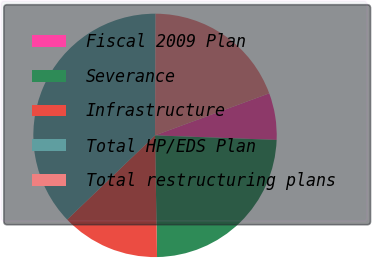Convert chart to OTSL. <chart><loc_0><loc_0><loc_500><loc_500><pie_chart><fcel>Fiscal 2009 Plan<fcel>Severance<fcel>Infrastructure<fcel>Total HP/EDS Plan<fcel>Total restructuring plans<nl><fcel>6.21%<fcel>24.14%<fcel>13.1%<fcel>37.24%<fcel>19.31%<nl></chart> 